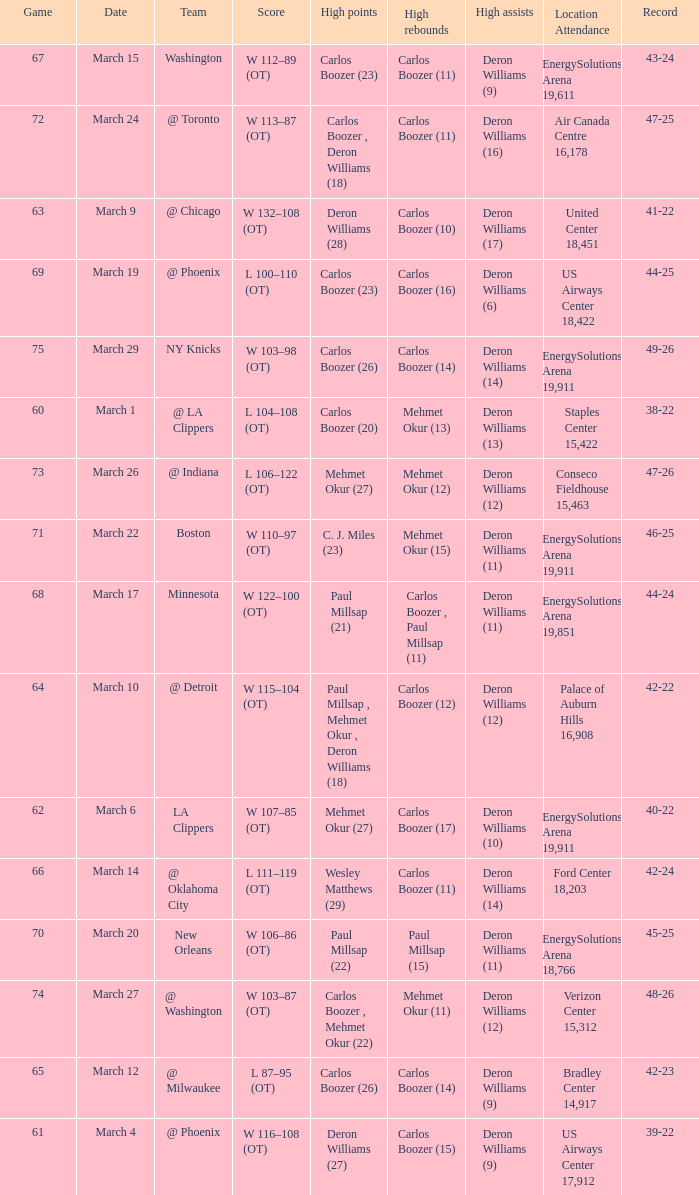Where was the March 24 game played? Air Canada Centre 16,178. 